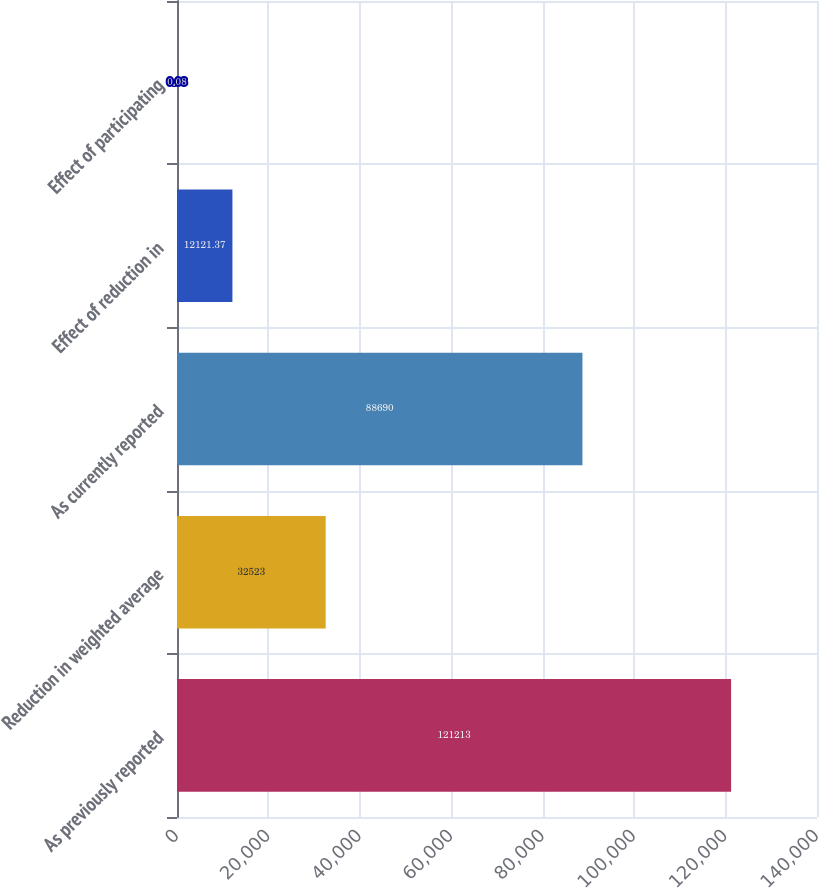<chart> <loc_0><loc_0><loc_500><loc_500><bar_chart><fcel>As previously reported<fcel>Reduction in weighted average<fcel>As currently reported<fcel>Effect of reduction in<fcel>Effect of participating<nl><fcel>121213<fcel>32523<fcel>88690<fcel>12121.4<fcel>0.08<nl></chart> 